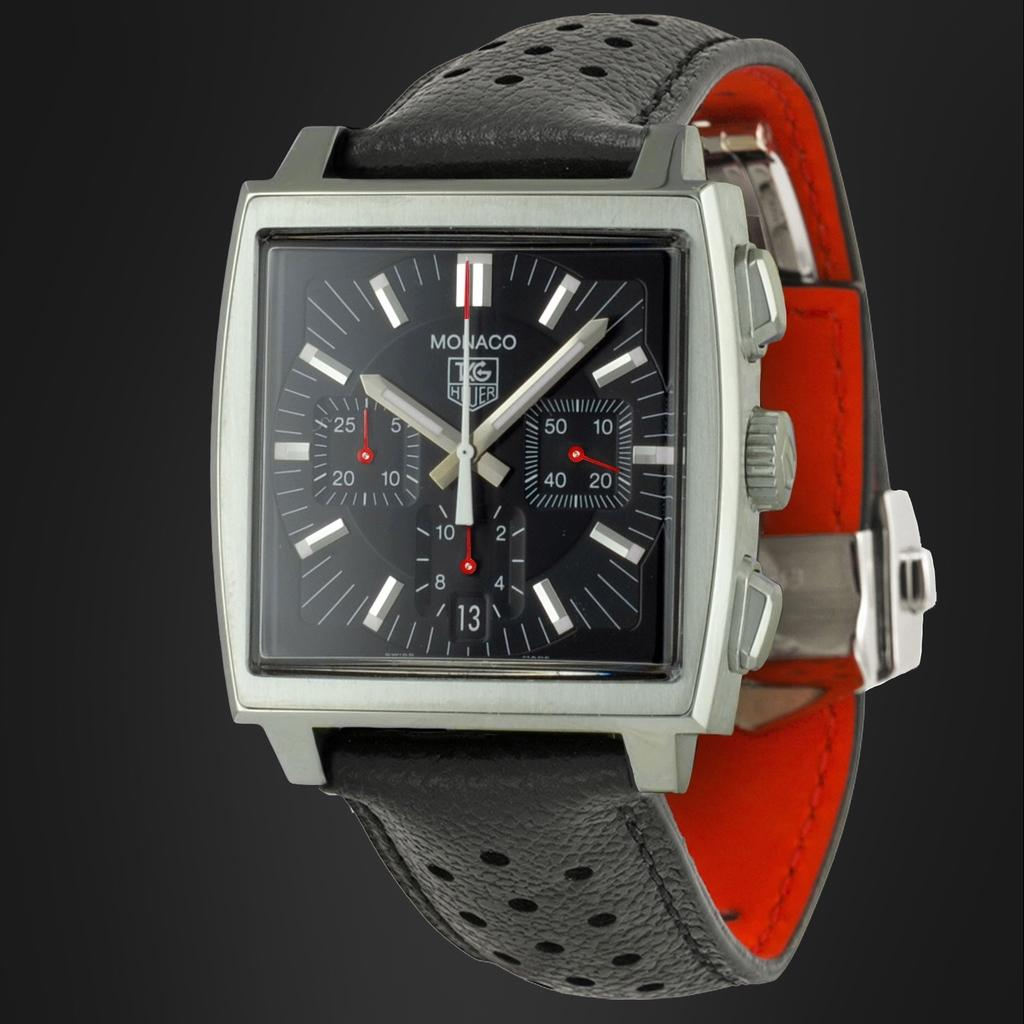<image>
Write a terse but informative summary of the picture. A watch has the Monaco brand logo on the face. 